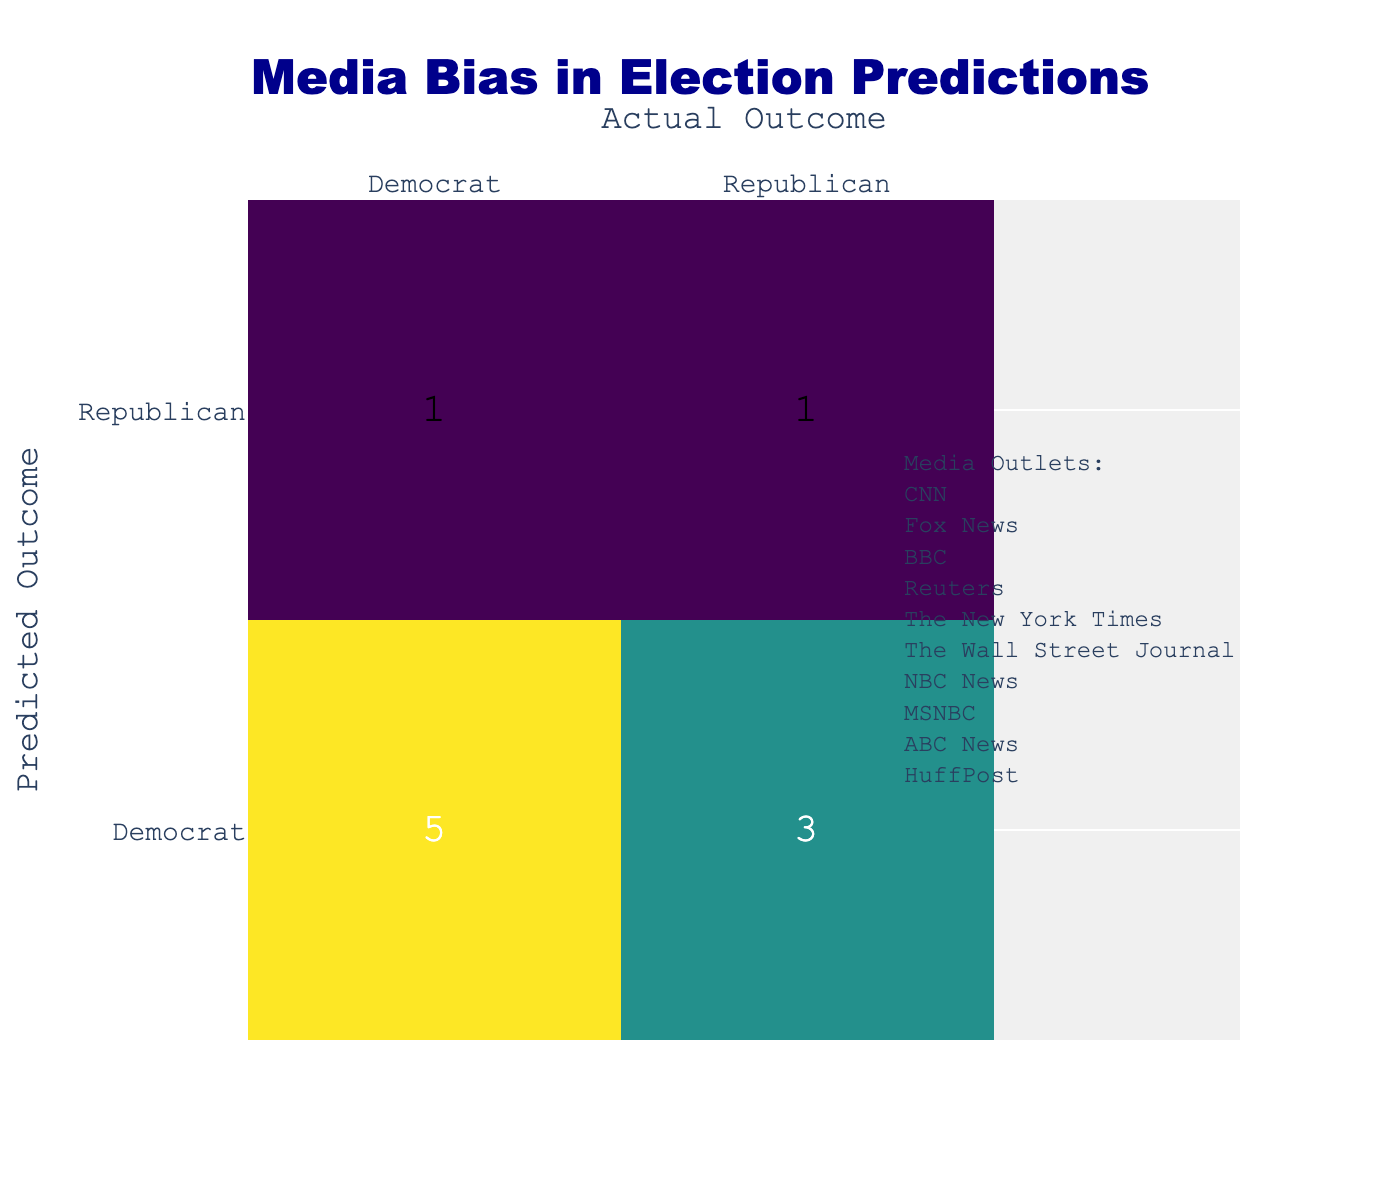What is the predicted outcome for CNN? According to the table, CNN predicted a Democrat outcome.
Answer: Democrat How many media outlets predicted a Republican outcome? By reviewing the table, only Fox News and The Wall Street Journal predicted a Republican outcome, totaling 2 outlets.
Answer: 2 Which media outlet had a correct prediction? The media outlets that predicted correctly include CNN, Reuters, The New York Times, NBC News, and ABC News, all of which predicted Democrat, matching the actual outcome.
Answer: CNN, Reuters, The New York Times, NBC News, ABC News What is the total number of correct predictions? We count the correct predictions: CNN, Reuters, The New York Times, NBC News, and ABC News (5) are correct predictions for Democrat, while Fox News is correct for Republican. Thus, there are 6 correct predictions (5 for Democrat and 1 for Republican).
Answer: 6 Did MSNBC make a correct prediction? MSNBC predicted a Democrat outcome, but the actual outcome was Republican, making their prediction incorrect.
Answer: No Which media outlet had the highest number of incorrect predictions? The Wall Street Journal and MSNBC both had one incorrect prediction, as they predicted a Republican outcome while the actual outcome was Democrat.
Answer: The Wall Street Journal and MSNBC What percentage of total predictions were correct? Total predictions are 10, and there are 6 correct predictions. The percentage of correct predictions: (6/10) * 100 = 60%.
Answer: 60% What is the difference between the number of correct predictions for Democrats versus Republicans? For Democrats, there are 5 correct predictions (CNN, Reuters, The New York Times, NBC News, ABC News), and for Republicans, there is 1 correct prediction (Fox News). Thus, the difference is 5 - 1 = 4.
Answer: 4 